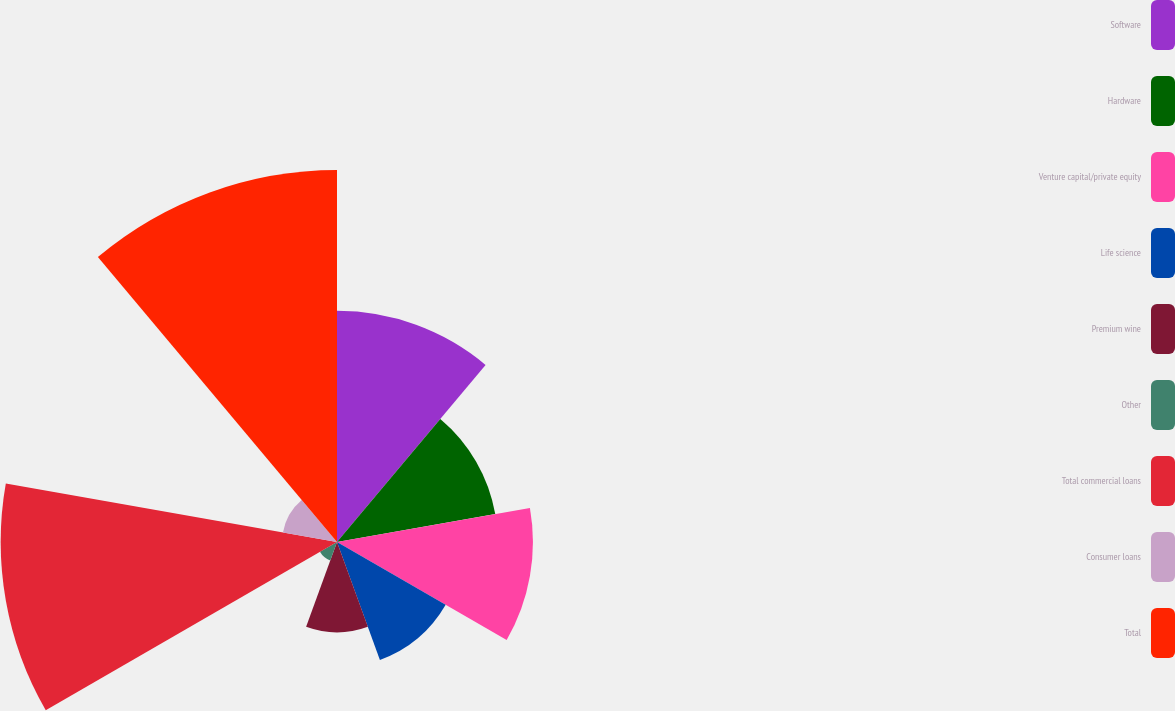<chart> <loc_0><loc_0><loc_500><loc_500><pie_chart><fcel>Software<fcel>Hardware<fcel>Venture capital/private equity<fcel>Life science<fcel>Premium wine<fcel>Other<fcel>Total commercial loans<fcel>Consumer loans<fcel>Total<nl><fcel>14.57%<fcel>10.13%<fcel>12.35%<fcel>7.91%<fcel>5.69%<fcel>1.24%<fcel>21.2%<fcel>3.46%<fcel>23.45%<nl></chart> 